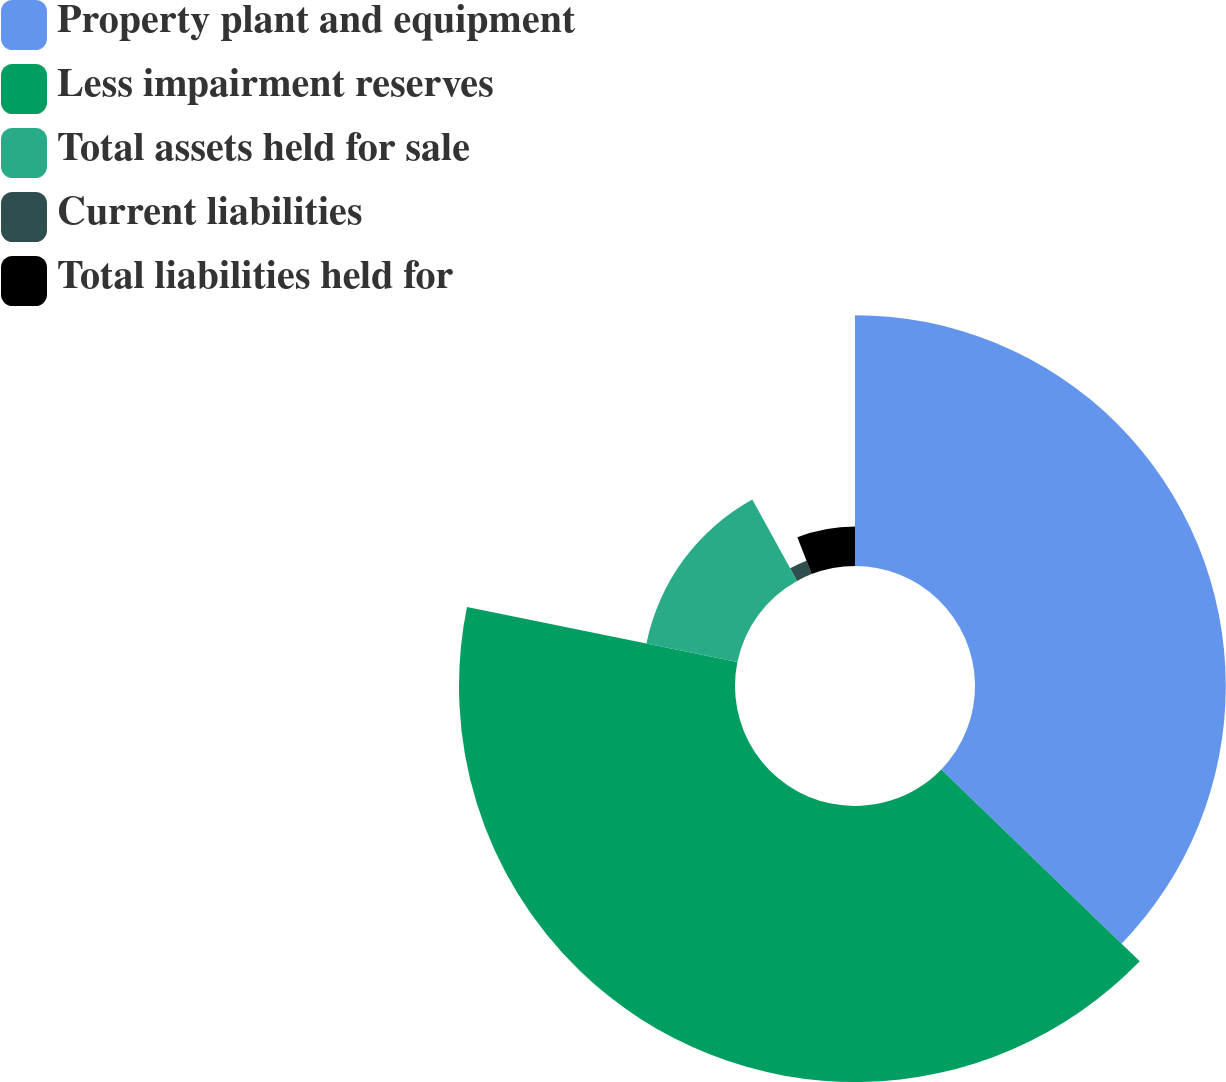<chart> <loc_0><loc_0><loc_500><loc_500><pie_chart><fcel>Property plant and equipment<fcel>Less impairment reserves<fcel>Total assets held for sale<fcel>Current liabilities<fcel>Total liabilities held for<nl><fcel>37.23%<fcel>40.97%<fcel>13.79%<fcel>2.13%<fcel>5.88%<nl></chart> 